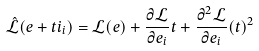Convert formula to latex. <formula><loc_0><loc_0><loc_500><loc_500>\mathcal { \hat { L } } ( { e } + t i _ { i } ) = \mathcal { L } ( e ) + \frac { \partial \mathcal { L } } { \partial { e } _ { i } } t + \frac { \partial ^ { 2 } \mathcal { L } } { \partial { e } _ { i } } ( t ) ^ { 2 }</formula> 